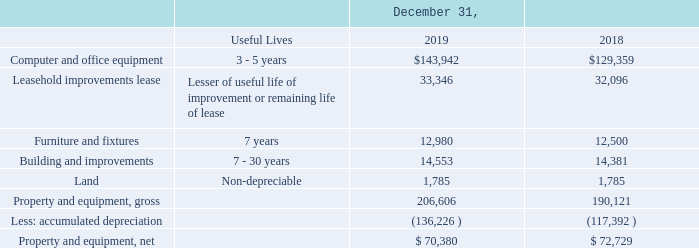Property and Equipment
Property and equipment are stated at cost. Depreciation of these assets is generally computed using the straight-line method over their estimated useful lives based on asset class. As of December 31, 2019 and 2018, net property and equipment consisted of the following (in thousands):
How was depreciation of the assets generally computed by the company? Using the straight-line method over their estimated useful lives based on asset class. What was the useful lives of Furniture and Fixtures? 7 years. What was the cost of building and improvements in 2019?
Answer scale should be: thousand. 14,553. What was the change in cost of furniture and fixtures between 2018 and 2019?
Answer scale should be: thousand. 12,980-12,500
Answer: 480. What was the change in the cost of computer and office equipment between 2018 and 2019?
Answer scale should be: thousand. $143,942-$129,359
Answer: 14583. What was the percentage change in the cost of leasehold improvements lease between 2018 and 2019?
Answer scale should be: percent. (33,346-32,096)/32,096
Answer: 3.89. 